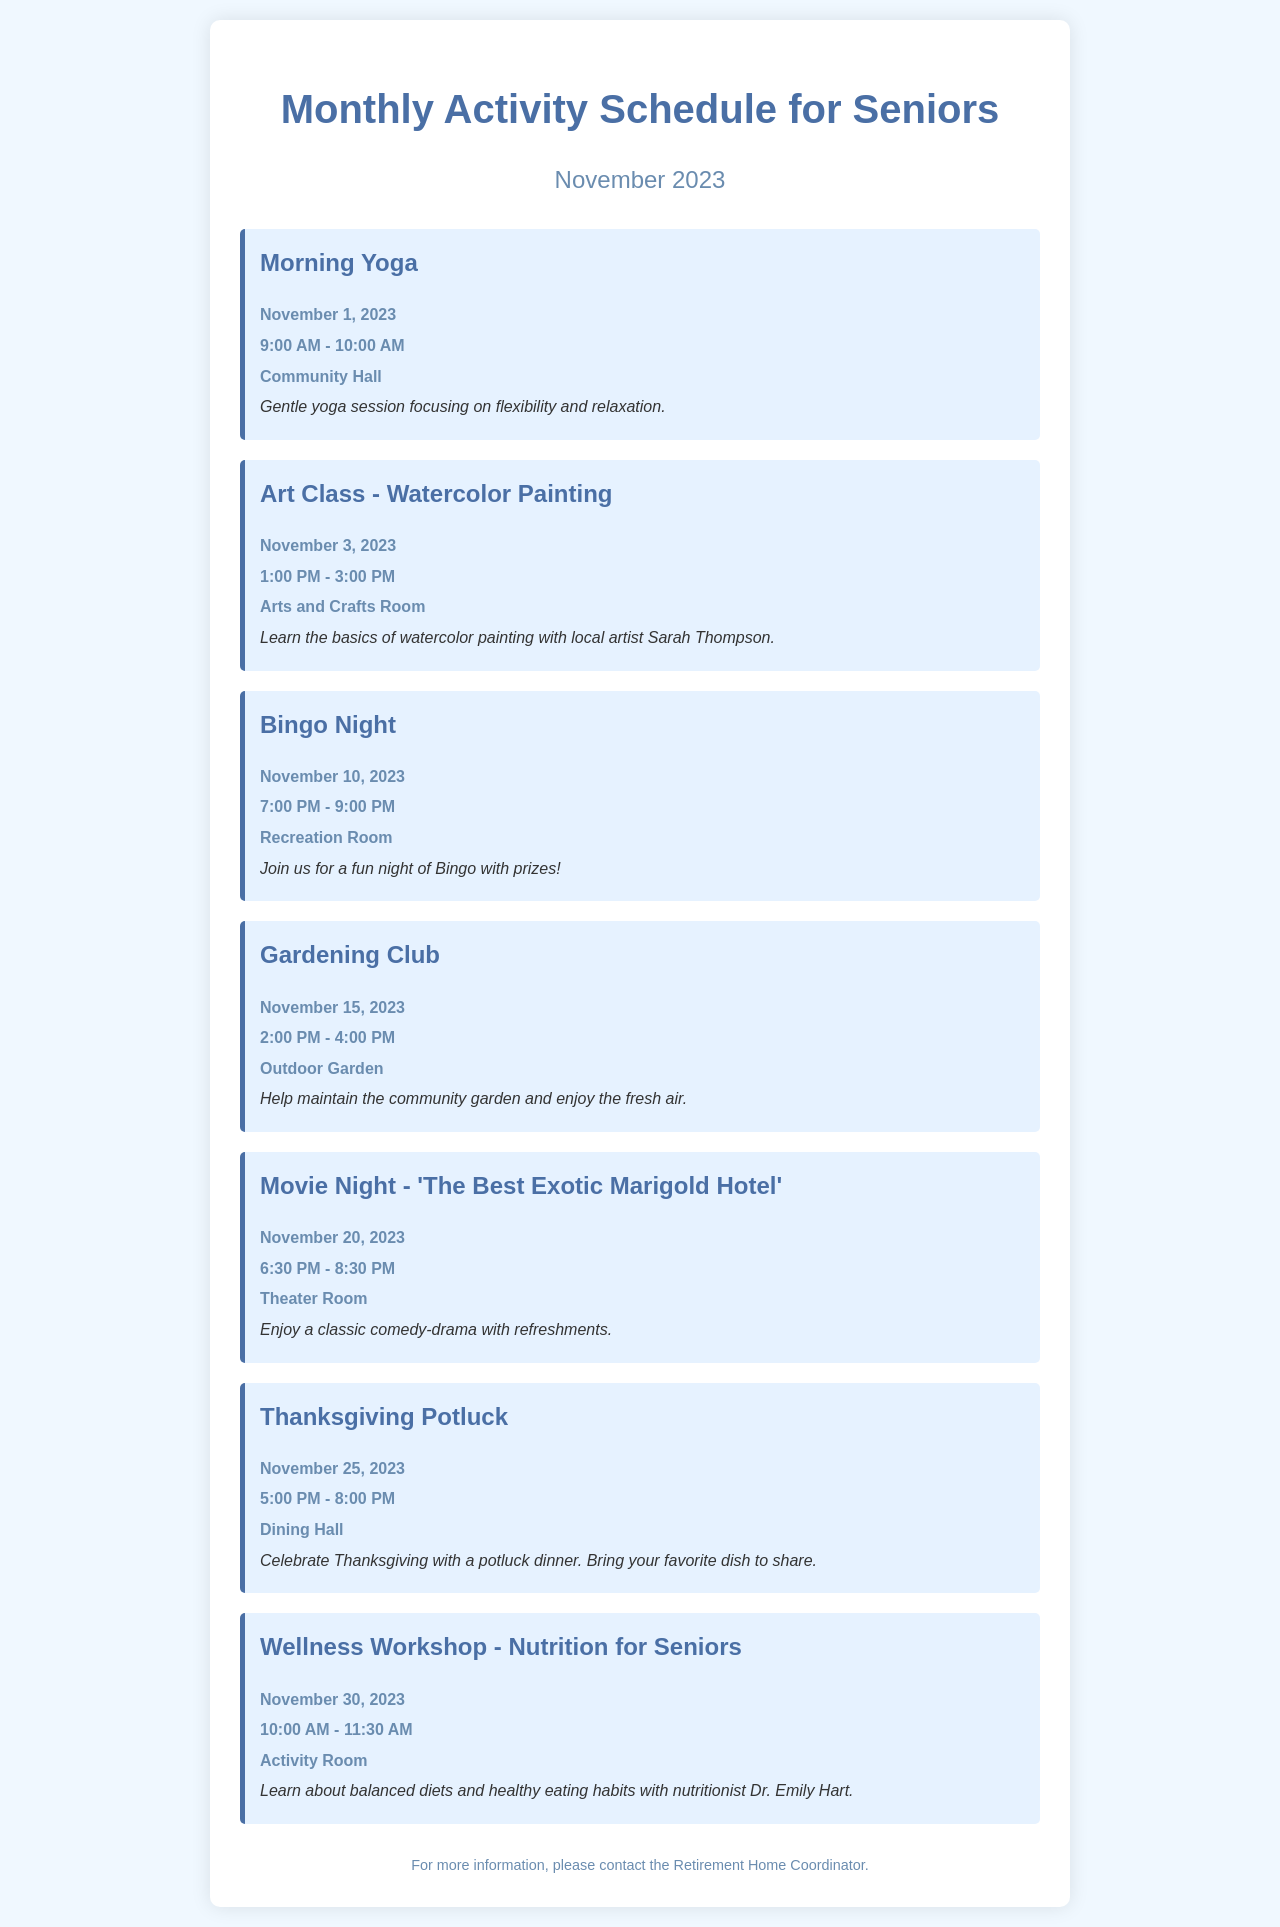What is the date of the Morning Yoga session? The document states the Morning Yoga session is scheduled for November 1, 2023.
Answer: November 1, 2023 What is the time for the Gardening Club event? The Gardening Club event is scheduled from 2:00 PM to 4:00 PM, as mentioned in the document.
Answer: 2:00 PM - 4:00 PM Where will the Thanksgiving Potluck take place? The document specifies that the Thanksgiving Potluck will be held in the Dining Hall.
Answer: Dining Hall Who is leading the Art Class? The document names local artist Sarah Thompson as the leader of the Art Class.
Answer: Sarah Thompson How long does the Movie Night last? According to the document, the Movie Night lasts for 2 hours, from 6:30 PM to 8:30 PM.
Answer: 2 hours How many activities are scheduled for November 2023? The document lists a total of six activities for the month of November.
Answer: Six What type of workshop is scheduled on November 30, 2023? The document indicates that a Wellness Workshop focused on Nutrition for Seniors is scheduled on that date.
Answer: Nutrition for Seniors What is the theme of the movie featured on November 20, 2023? The document describes the theme of the featured movie as a comedy-drama, specifically 'The Best Exotic Marigold Hotel'.
Answer: comedy-drama 